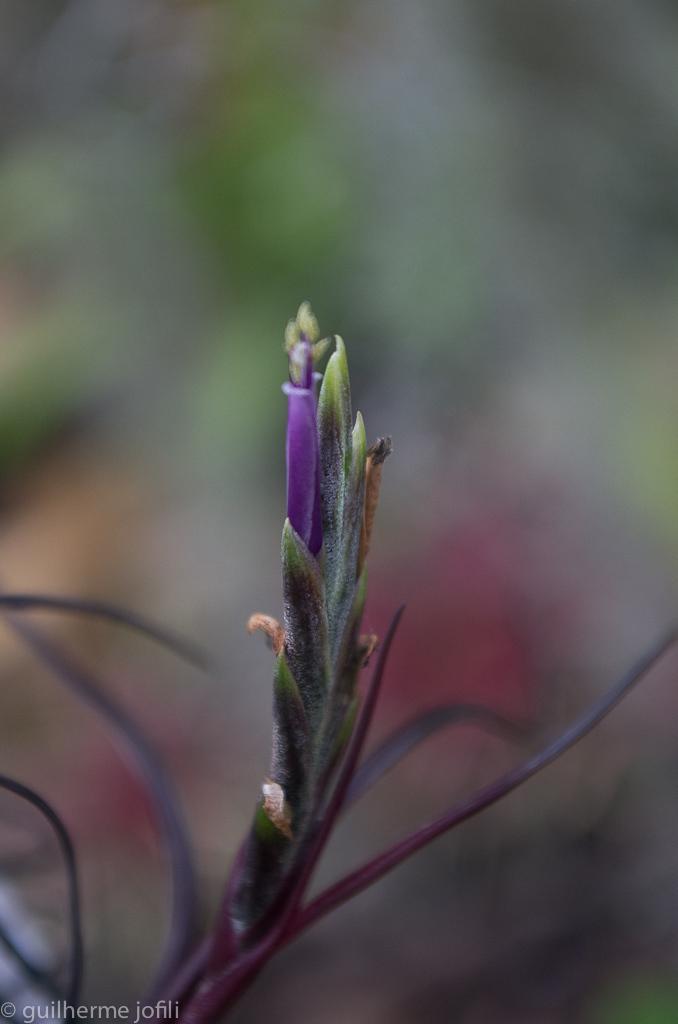Describe this image in one or two sentences. In this image we can see a plant which has a violet color flower and the background of the image is in a blur. 